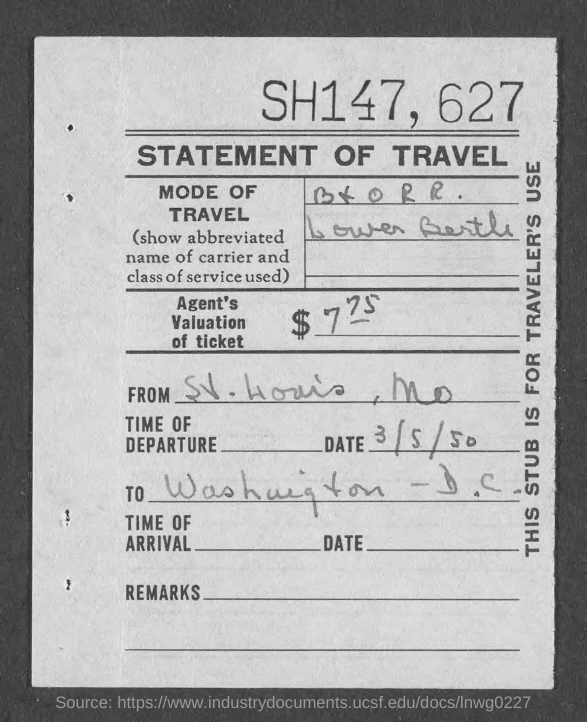Mention a couple of crucial points in this snapshot. The date of departure is March 5, 1950. The origin of the item is St. Louis, Missouri. The title of the document is 'Statement of Travel'. What is the purpose of the stub for? Travelers use it. 